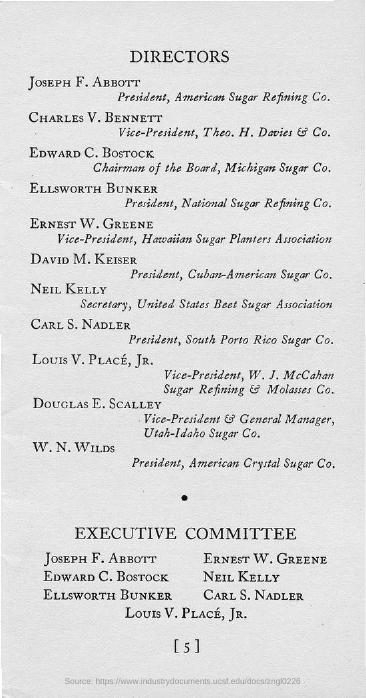Identify some key points in this picture. The chairman of the board of Michigan Sugar Co. is Edward C. Bostock. Joseph F. Abbott is the president of American Sugar Refining Co. 